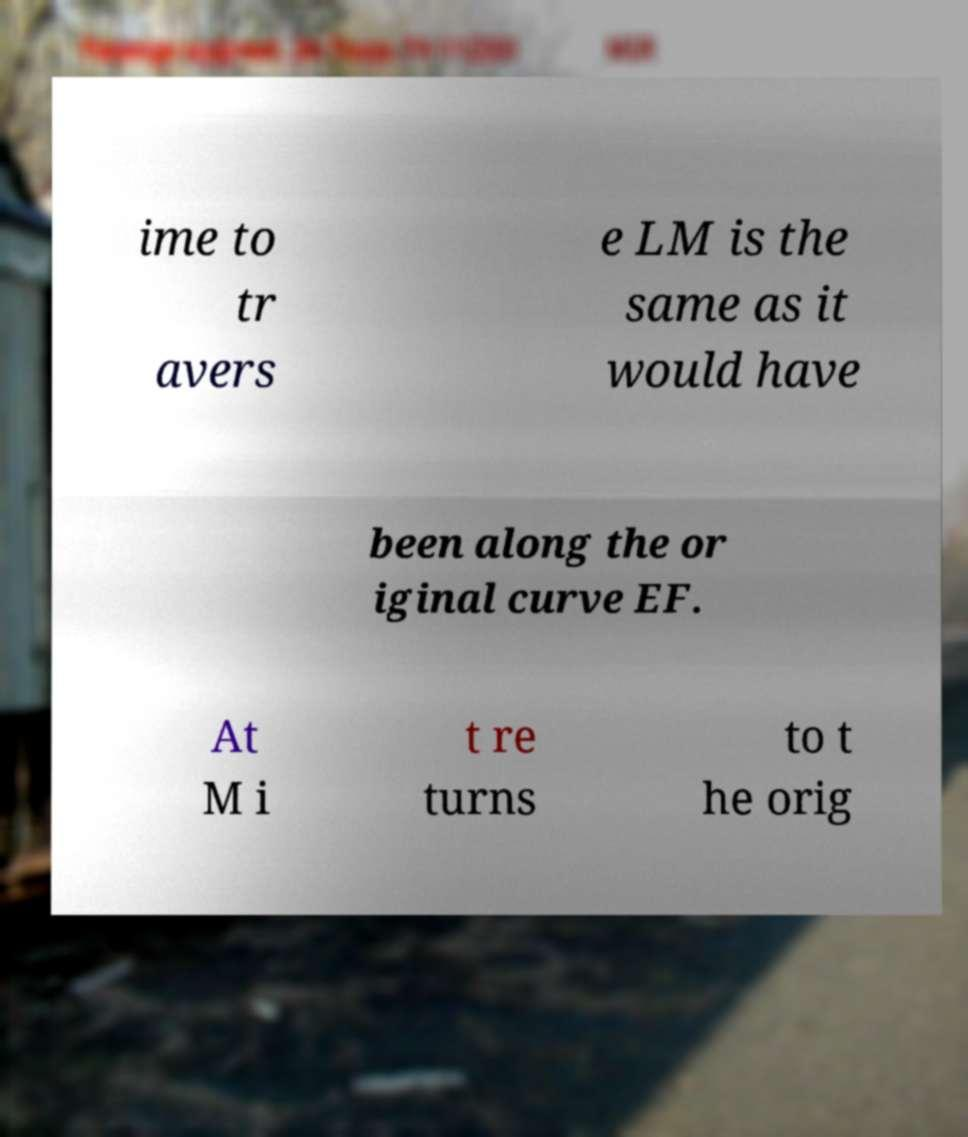Please identify and transcribe the text found in this image. ime to tr avers e LM is the same as it would have been along the or iginal curve EF. At M i t re turns to t he orig 